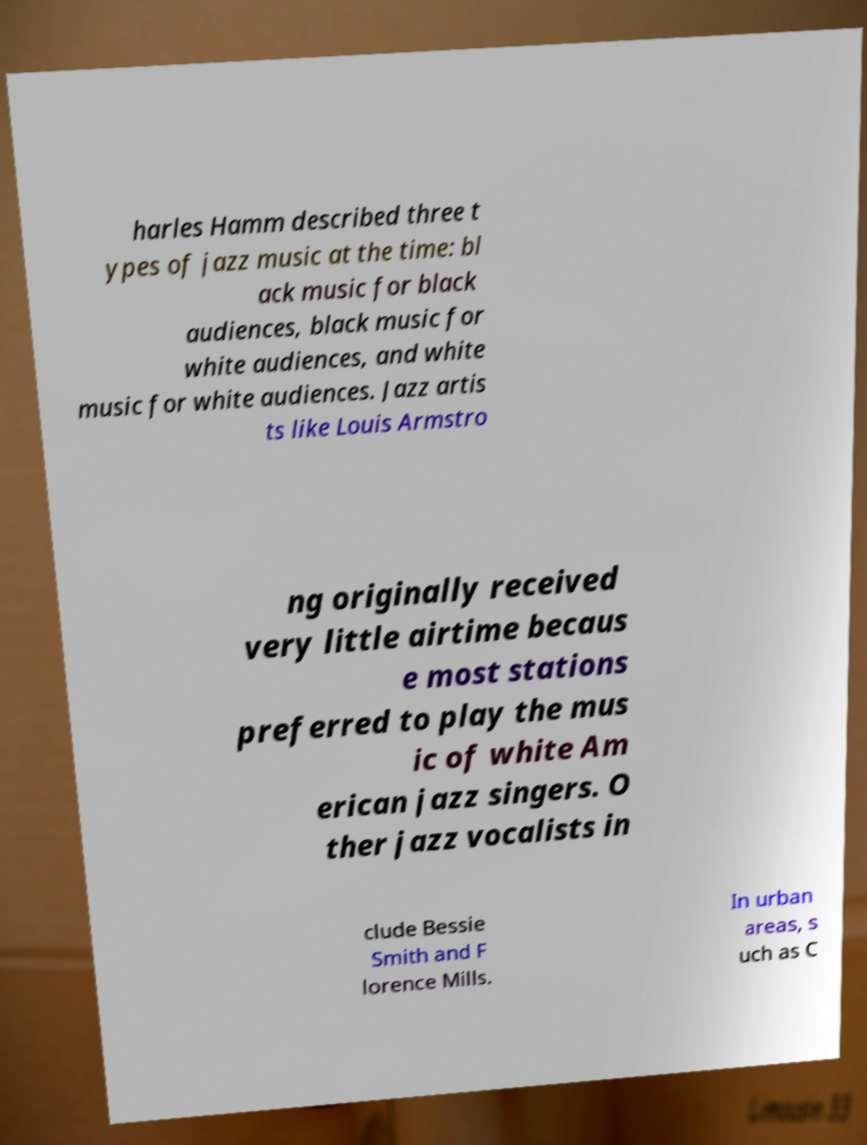What messages or text are displayed in this image? I need them in a readable, typed format. harles Hamm described three t ypes of jazz music at the time: bl ack music for black audiences, black music for white audiences, and white music for white audiences. Jazz artis ts like Louis Armstro ng originally received very little airtime becaus e most stations preferred to play the mus ic of white Am erican jazz singers. O ther jazz vocalists in clude Bessie Smith and F lorence Mills. In urban areas, s uch as C 